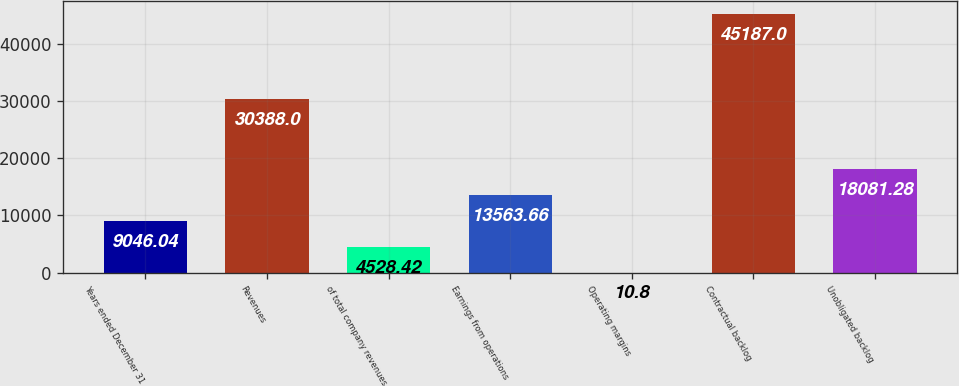Convert chart to OTSL. <chart><loc_0><loc_0><loc_500><loc_500><bar_chart><fcel>Years ended December 31<fcel>Revenues<fcel>of total company revenues<fcel>Earnings from operations<fcel>Operating margins<fcel>Contractual backlog<fcel>Unobligated backlog<nl><fcel>9046.04<fcel>30388<fcel>4528.42<fcel>13563.7<fcel>10.8<fcel>45187<fcel>18081.3<nl></chart> 